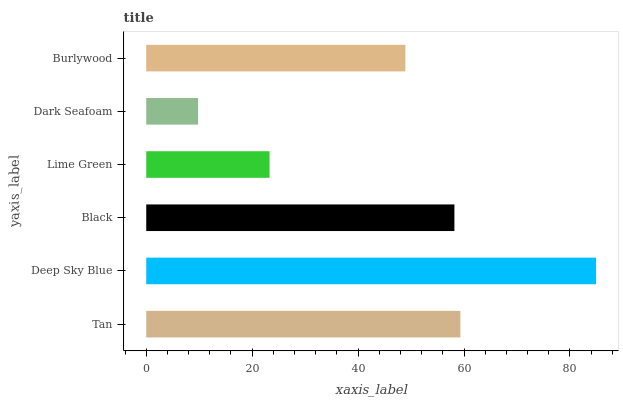Is Dark Seafoam the minimum?
Answer yes or no. Yes. Is Deep Sky Blue the maximum?
Answer yes or no. Yes. Is Black the minimum?
Answer yes or no. No. Is Black the maximum?
Answer yes or no. No. Is Deep Sky Blue greater than Black?
Answer yes or no. Yes. Is Black less than Deep Sky Blue?
Answer yes or no. Yes. Is Black greater than Deep Sky Blue?
Answer yes or no. No. Is Deep Sky Blue less than Black?
Answer yes or no. No. Is Black the high median?
Answer yes or no. Yes. Is Burlywood the low median?
Answer yes or no. Yes. Is Dark Seafoam the high median?
Answer yes or no. No. Is Deep Sky Blue the low median?
Answer yes or no. No. 